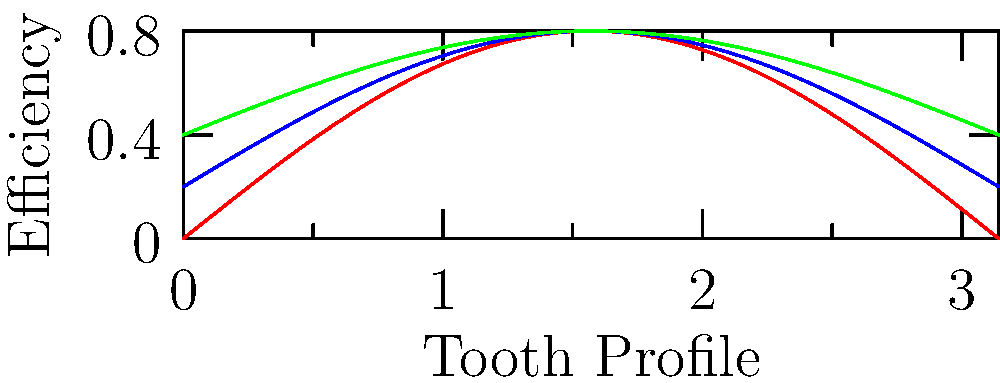In the context of promoting advanced engineering practices in Riyadh's cultural landscape, which gear tooth profile shown in the graph demonstrates the highest efficiency in power transmission, and why might this be significant for local industrial development? To answer this question, let's analyze the graph step-by-step:

1. The graph shows three different gear tooth profiles: Involute (red), Cycloidal (blue), and Straight (green).

2. The y-axis represents efficiency, with higher values indicating better performance.

3. Examining the curves:
   - The red curve (Involute) reaches the highest peak, around 0.8 on the efficiency scale.
   - The blue curve (Cycloidal) peaks at about 0.6 to 0.7.
   - The green curve (Straight) has the lowest peak, around 0.4 to 0.5.

4. The Involute profile consistently shows higher efficiency across the tooth profile (x-axis).

5. This higher efficiency of the Involute profile is significant because:
   a) It results in less energy loss during power transmission.
   b) It leads to reduced wear and longer gear life.
   c) It allows for smoother and quieter operation.

6. For Riyadh's industrial development, adopting the most efficient gear profile could:
   a) Improve the performance of local manufacturing and processing plants.
   b) Reduce energy consumption, aligning with sustainability goals.
   c) Enhance the competitiveness of locally produced machinery and equipment.

Therefore, the Involute gear tooth profile demonstrates the highest efficiency in power transmission, which could significantly contribute to the advancement of Riyadh's industrial sector.
Answer: Involute profile, due to highest efficiency peak (≈0.8) and consistent performance. 